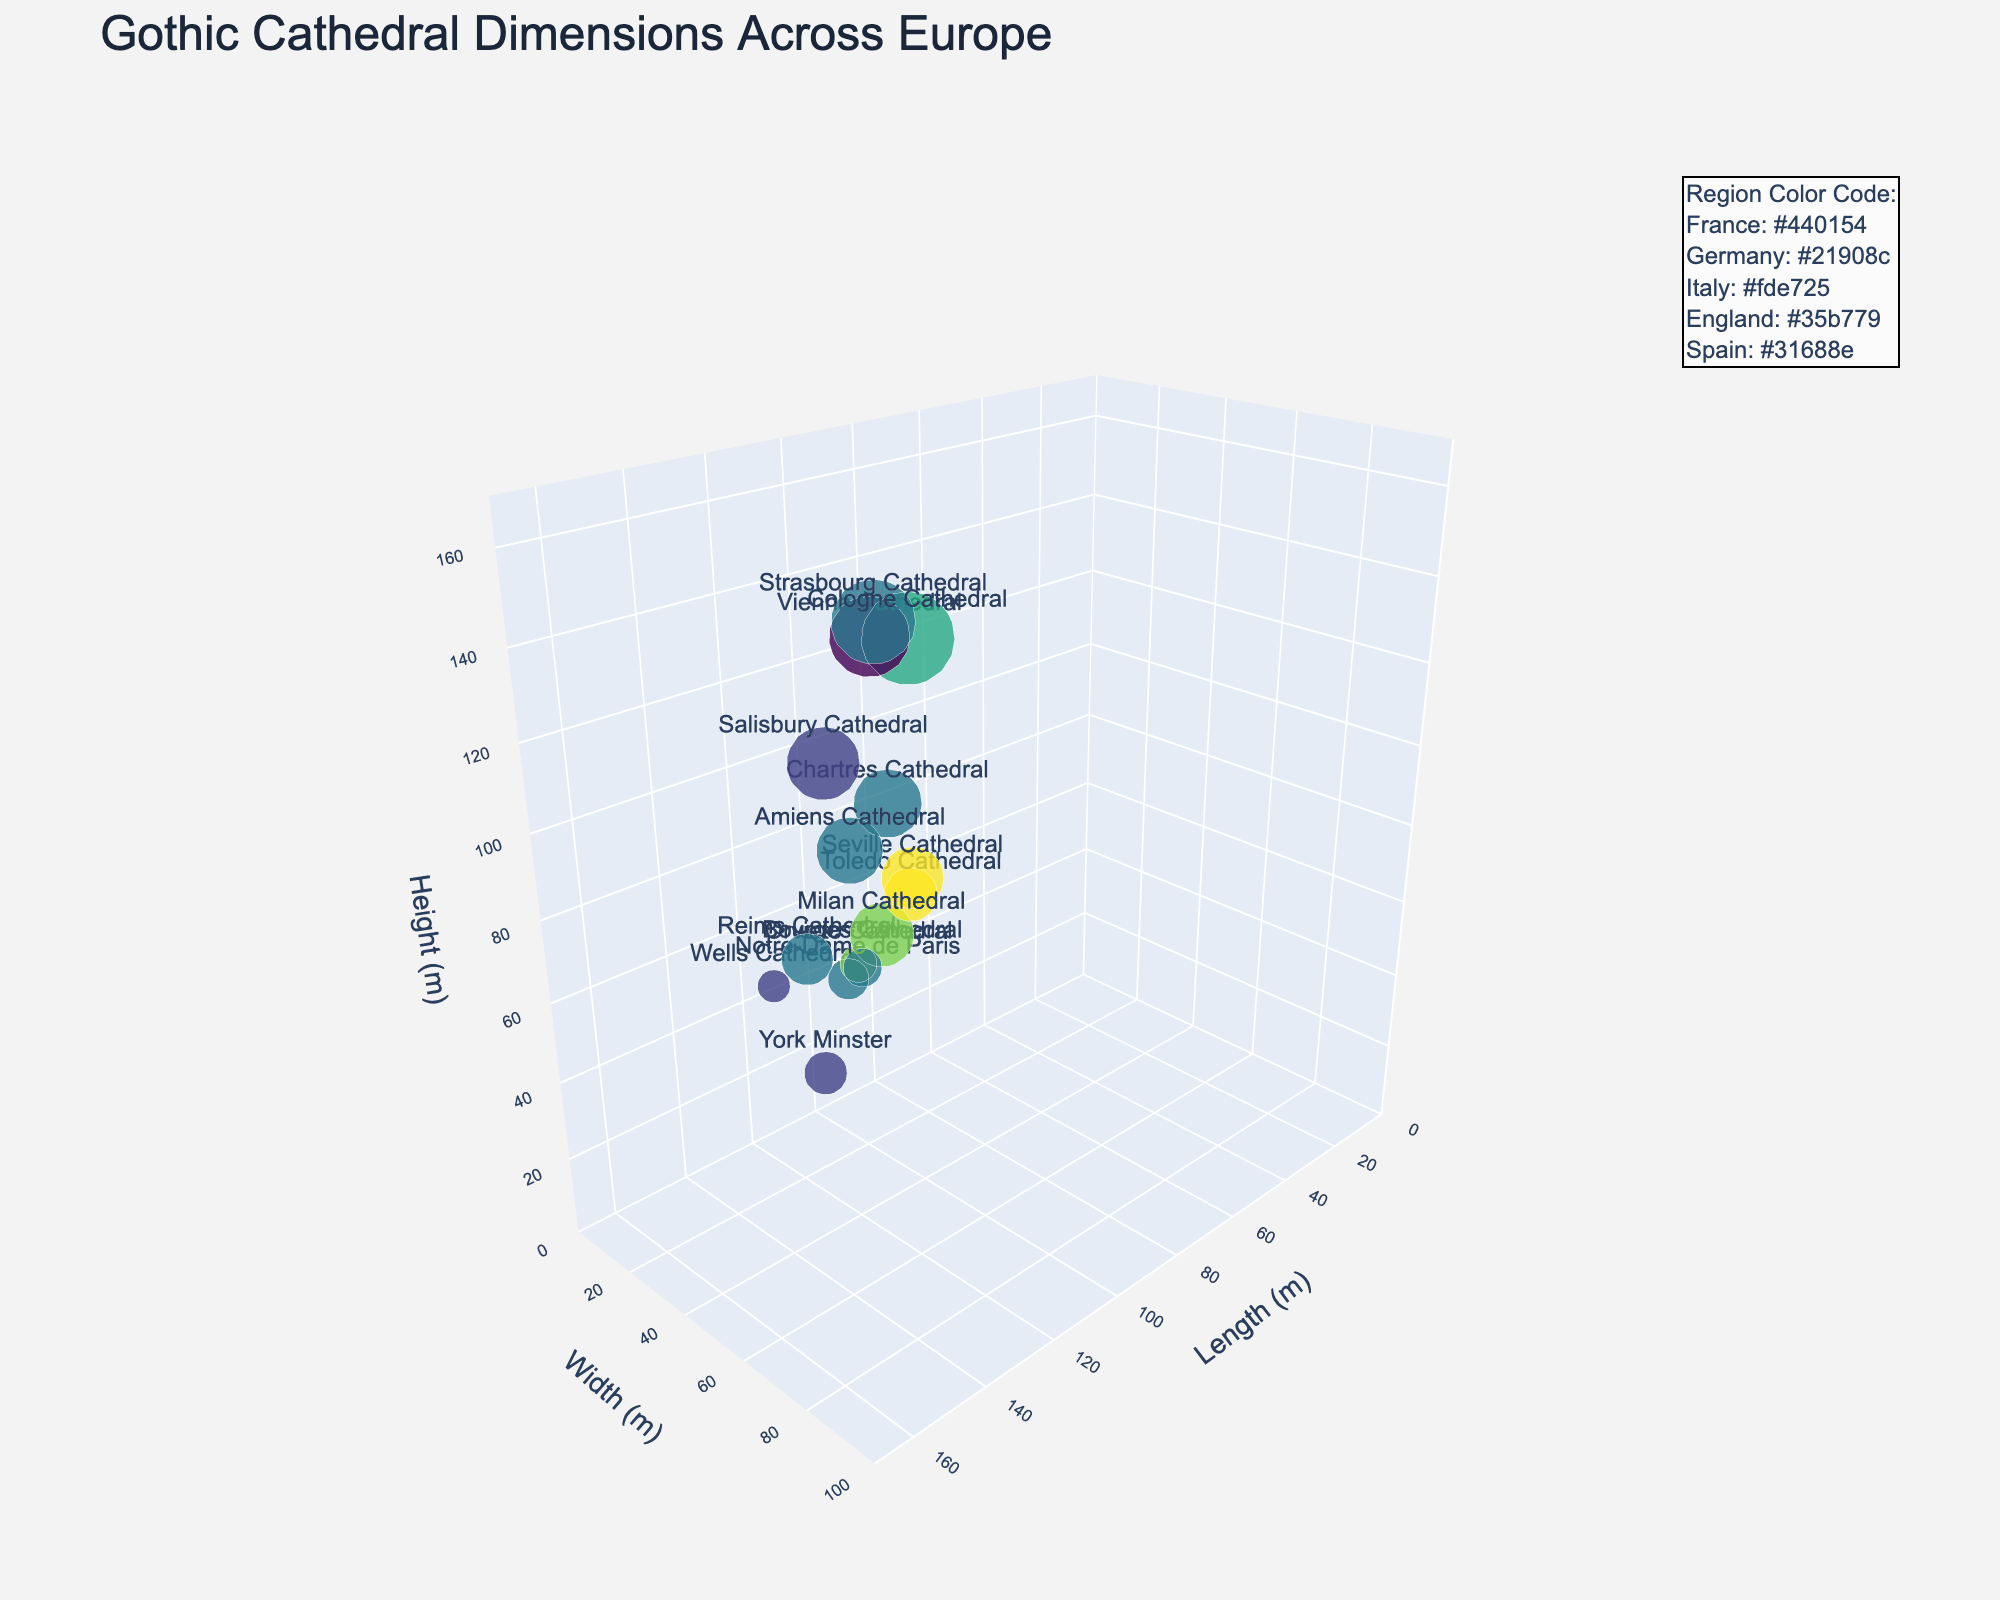What's the title of the plot? The title is located at the top of the plot. It reads "Gothic Cathedral Dimensions Across Europe".
Answer: Gothic Cathedral Dimensions Across Europe What are the three axes representing? The plot has three labeled axes. The x-axis represents "Length (m)", the y-axis represents "Width (m)", and the z-axis represents "Height (m)".
Answer: Length, Width, Height Which cathedral has the highest height, and what is it? To find the cathedral with the highest height, look for the highest point on the z-axis. The hover text will show that Cologne Cathedral has the highest height of 157 meters.
Answer: Cologne Cathedral, 157 meters How many cathedrals are plotted from France? Identify the color assigned to the French cathedrals and count them. The hover text shows there are 6 cathedrals from France in the plot.
Answer: 6 Which cathedral has approximately equal length and width dimensions? Look for a point where length and width are nearly the same. The hover text shows Cologne Cathedral has a length of 144 meters and width of 86 meters, which are close.
Answer: Cologne Cathedral What's the average height of the cathedrals from England? The heights of the cathedrals from England are 72, 55, and 123 meters. Add these values and divide by the number of cathedrals: (72 + 55 + 123) / 3.
Answer: 83.33 meters Which region has the most representation in the plot? Refer to the hover text to count the number of cathedrals from each region. France has the most representations with 6 cathedrals.
Answer: France What is the smallest cathedral in terms of width and which cathedral is it? To find the smallest width, look at the points with the smallest y-values. Hover text shows Wells Cathedral has the smallest width of 20 meters.
Answer: Wells Cathedral, 20 meters What's the total length of all cathedrals combined? Sum the lengths of all cathedrals: 128 + 144 + 158 + 158 + 135 + 130 + 149 + 126 + 107 + 138 + 145 + 112 + 120 + 114 + 118.
Answer: 1982 meters Which two cathedrals have the same height but are from different regions? Look for points with the same z-axis values. York Minster and Seville Cathedral both have a height of 105 meters.
Answer: York Minster and Seville Cathedral 